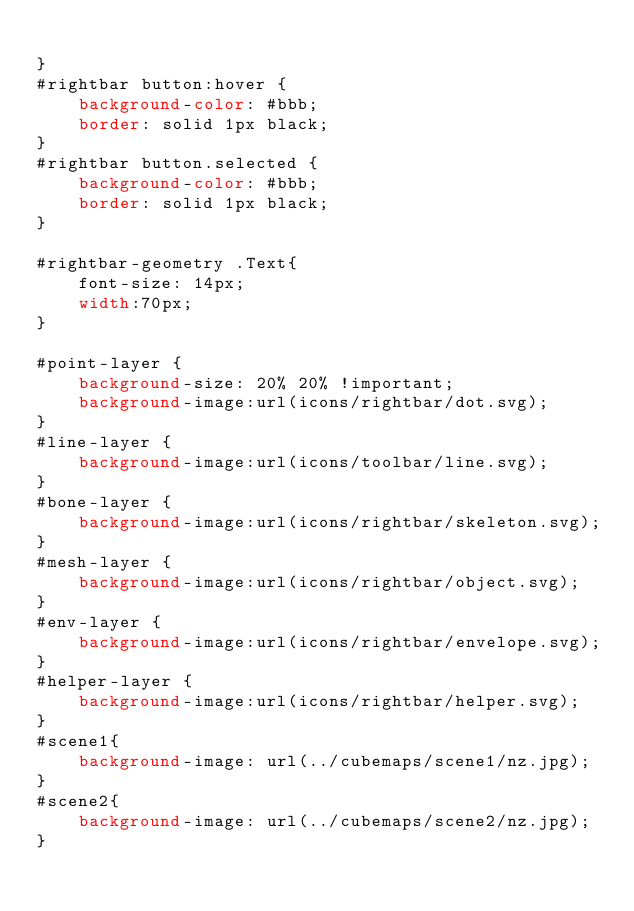<code> <loc_0><loc_0><loc_500><loc_500><_CSS_>
}
#rightbar button:hover {
	background-color: #bbb;
	border: solid 1px black;
}
#rightbar button.selected {
	background-color: #bbb;
	border: solid 1px black;
}

#rightbar-geometry .Text{
	font-size: 14px;
	width:70px;
}

#point-layer {
	background-size: 20% 20% !important;
	background-image:url(icons/rightbar/dot.svg);
}
#line-layer {
	background-image:url(icons/toolbar/line.svg);
}
#bone-layer {
	background-image:url(icons/rightbar/skeleton.svg);
}
#mesh-layer {
	background-image:url(icons/rightbar/object.svg);
}
#env-layer {
	background-image:url(icons/rightbar/envelope.svg);
}
#helper-layer {
	background-image:url(icons/rightbar/helper.svg);
}
#scene1{
	background-image: url(../cubemaps/scene1/nz.jpg);
}
#scene2{
	background-image: url(../cubemaps/scene2/nz.jpg);
}</code> 